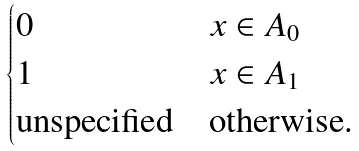Convert formula to latex. <formula><loc_0><loc_0><loc_500><loc_500>\begin{cases} 0 & x \in A _ { 0 } \\ 1 & x \in A _ { 1 } \\ \text {unspecified} & \text {otherwise.} \end{cases}</formula> 